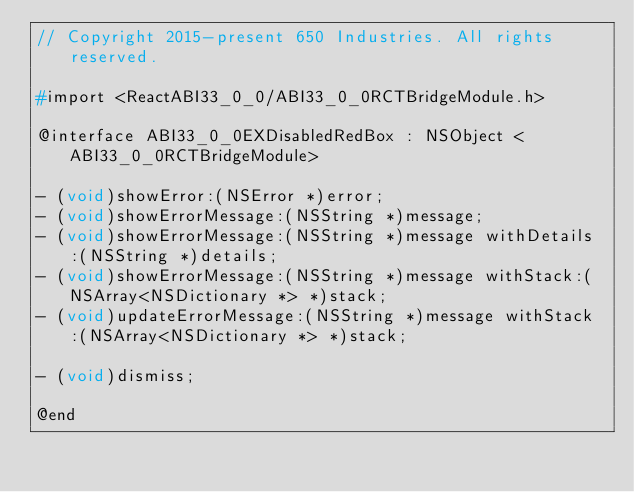<code> <loc_0><loc_0><loc_500><loc_500><_C_>// Copyright 2015-present 650 Industries. All rights reserved.

#import <ReactABI33_0_0/ABI33_0_0RCTBridgeModule.h>

@interface ABI33_0_0EXDisabledRedBox : NSObject <ABI33_0_0RCTBridgeModule>

- (void)showError:(NSError *)error;
- (void)showErrorMessage:(NSString *)message;
- (void)showErrorMessage:(NSString *)message withDetails:(NSString *)details;
- (void)showErrorMessage:(NSString *)message withStack:(NSArray<NSDictionary *> *)stack;
- (void)updateErrorMessage:(NSString *)message withStack:(NSArray<NSDictionary *> *)stack;

- (void)dismiss;

@end
</code> 